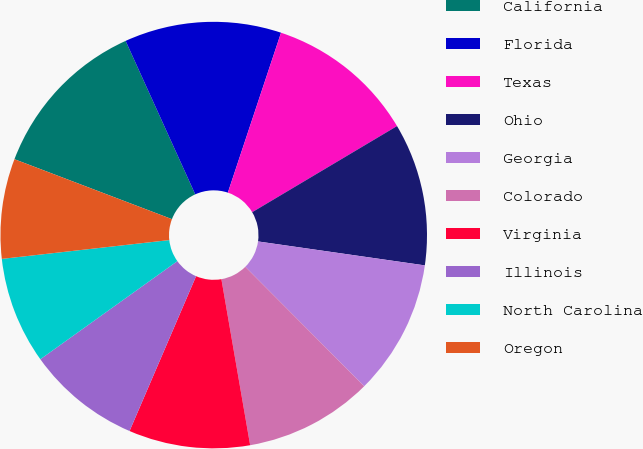Convert chart. <chart><loc_0><loc_0><loc_500><loc_500><pie_chart><fcel>California<fcel>Florida<fcel>Texas<fcel>Ohio<fcel>Georgia<fcel>Colorado<fcel>Virginia<fcel>Illinois<fcel>North Carolina<fcel>Oregon<nl><fcel>12.43%<fcel>11.89%<fcel>11.35%<fcel>10.81%<fcel>10.27%<fcel>9.73%<fcel>9.19%<fcel>8.65%<fcel>8.11%<fcel>7.57%<nl></chart> 